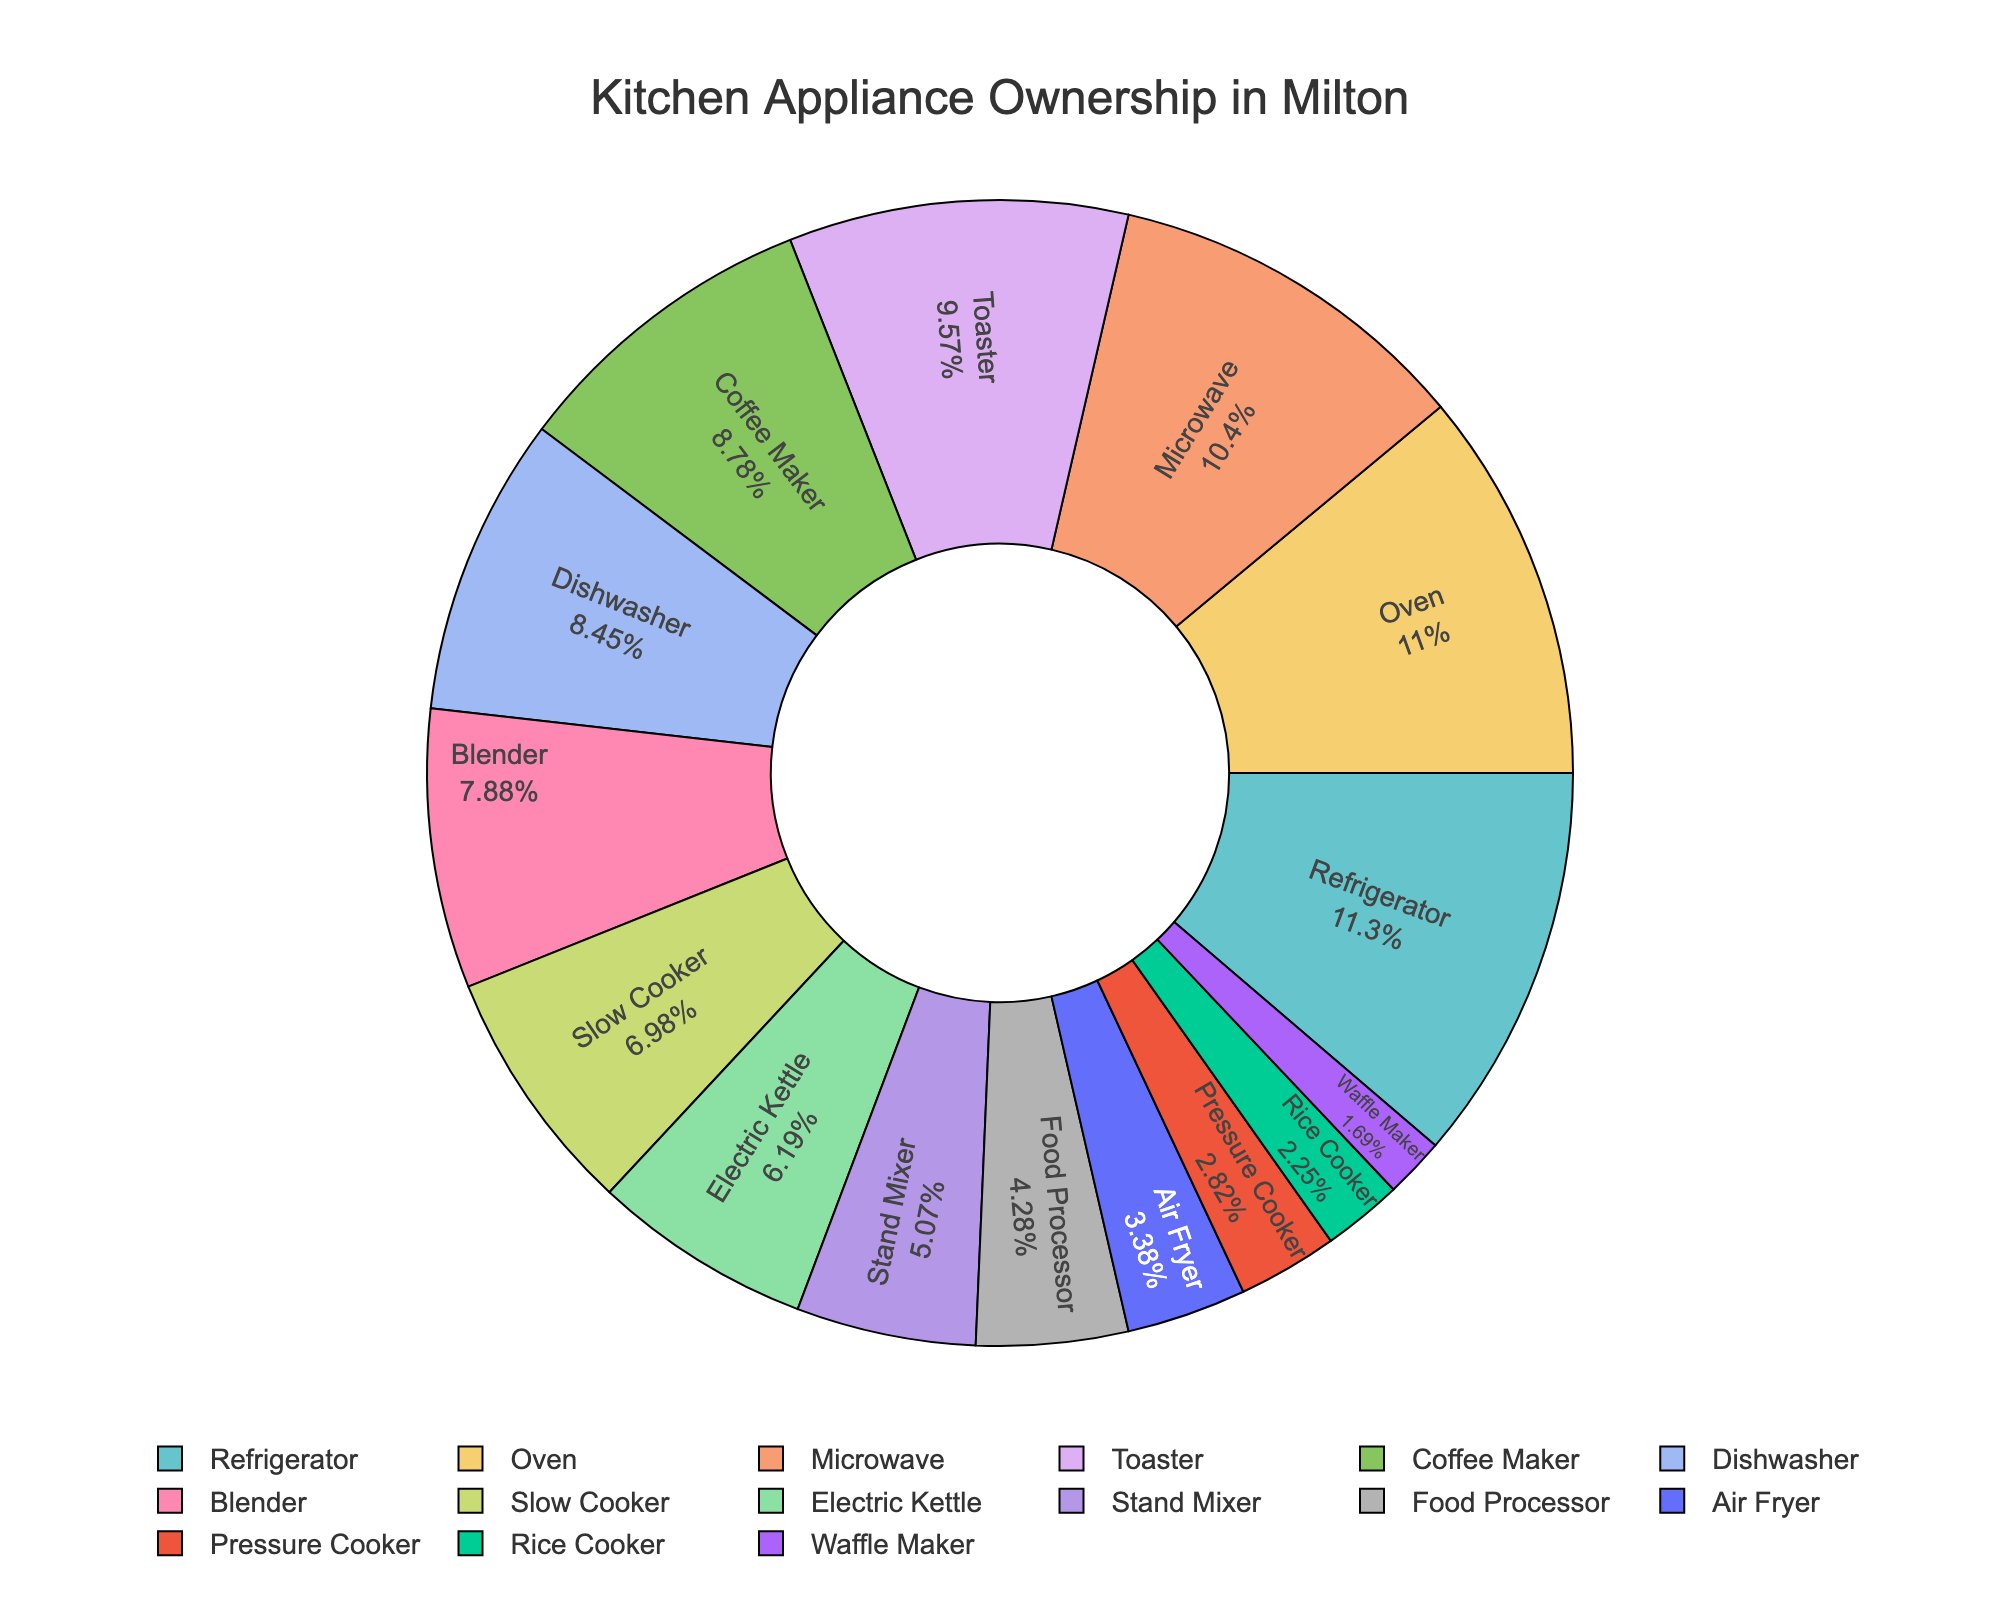What's the most commonly owned kitchen appliance among Milton residents? The pie chart shows that the refrigerator has the highest ownership percentage at 100%, indicating it is the most commonly owned appliance.
Answer: Refrigerator Which appliance has higher ownership, the slow cooker or the blender? Looking at the pie chart, the blender has an ownership percentage of 70%, while the slow cooker has 62%. Therefore, the blender has higher ownership.
Answer: Blender What's the total ownership percentage of the microwave, toaster, and coffee maker combined? The microwave has an ownership of 92%, the toaster has 85%, and the coffee maker has 78%. Summing them up gives 92 + 85 + 78 = 255%.
Answer: 255% Are air fryers more or less common than electric kettles? The pie chart reveals that air fryers have an ownership percentage of 30%, whereas electric kettles have 55%. Therefore, air fryers are less common than electric kettles.
Answer: Less common How many appliances have an ownership percentage of 50% or less? From the pie chart, the appliances with ownership percentages of 50% or less are the stand mixer (45%), food processor (38%), air fryer (30%), pressure cooker (25%), rice cooker (20%), and waffle maker (15%). This totals to 6 appliances.
Answer: 6 What is the difference between the ownership percentages of the oven and the pressure cooker? The ownership percentage of the oven is 98%, and the pressure cooker is 25%. The difference is 98 - 25 = 73.
Answer: 73 Which is more common, dishwashers or coffee makers? The pie chart shows that dishwashers have an ownership percentage of 75%, while coffee makers have 78%. Therefore, coffee makers are more common.
Answer: Coffee makers What percentage of residents own at least one type of kettle or cooker (electric kettle, slow cooker, pressure cooker, rice cooker)? Adding the ownership percentages of the electric kettle (55%), slow cooker (62%), pressure cooker (25%), and rice cooker (20%) gives 55 + 62 + 25 + 20 = 162%.
Answer: 162% Can blenders be considered more essential than stand mixers based on their ownership? The pie chart indicates that blenders have a 70% ownership compared to stand mixers' 45%. Higher ownership suggests that blenders are considered more essential.
Answer: Yes 